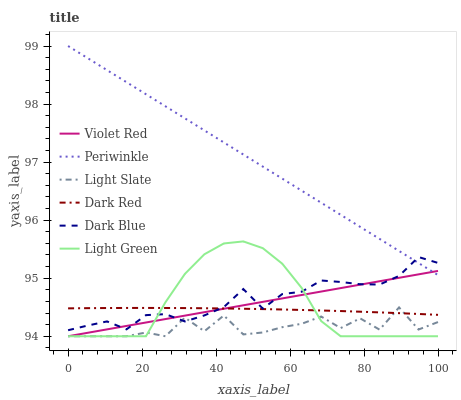Does Light Slate have the minimum area under the curve?
Answer yes or no. Yes. Does Periwinkle have the maximum area under the curve?
Answer yes or no. Yes. Does Dark Red have the minimum area under the curve?
Answer yes or no. No. Does Dark Red have the maximum area under the curve?
Answer yes or no. No. Is Violet Red the smoothest?
Answer yes or no. Yes. Is Light Slate the roughest?
Answer yes or no. Yes. Is Dark Red the smoothest?
Answer yes or no. No. Is Dark Red the roughest?
Answer yes or no. No. Does Dark Red have the lowest value?
Answer yes or no. No. Does Periwinkle have the highest value?
Answer yes or no. Yes. Does Light Slate have the highest value?
Answer yes or no. No. Is Light Slate less than Periwinkle?
Answer yes or no. Yes. Is Periwinkle greater than Light Slate?
Answer yes or no. Yes. Does Light Slate intersect Dark Red?
Answer yes or no. Yes. Is Light Slate less than Dark Red?
Answer yes or no. No. Is Light Slate greater than Dark Red?
Answer yes or no. No. Does Light Slate intersect Periwinkle?
Answer yes or no. No. 